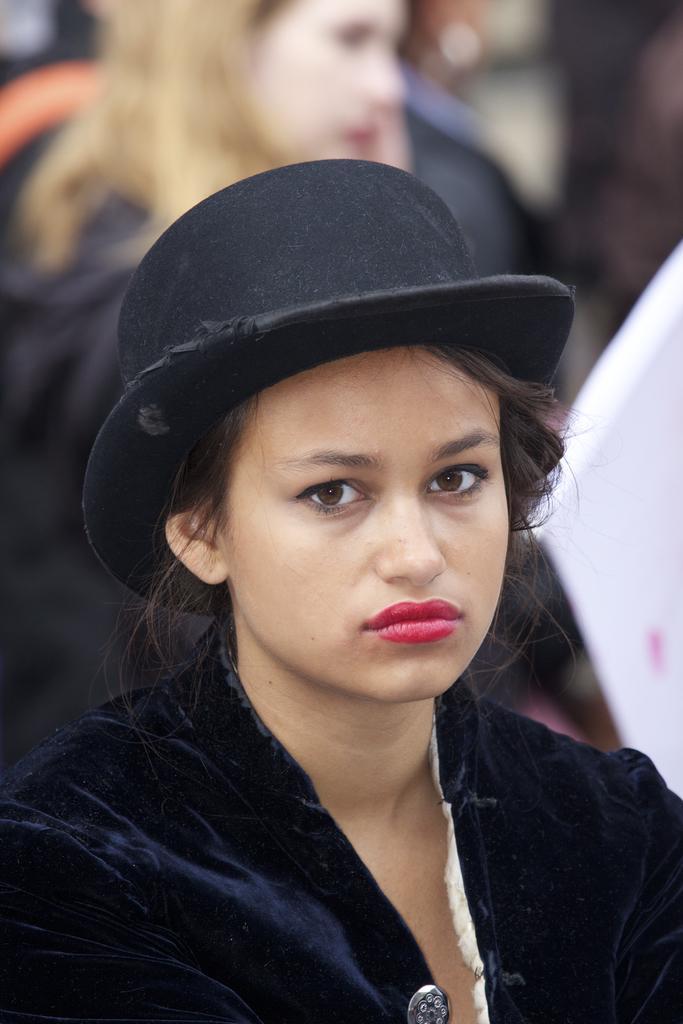How would you summarize this image in a sentence or two? At the bottom of this image, there is a woman wearing a black color cap and watching something. In the background, there is another woman. And the background is blurred. 